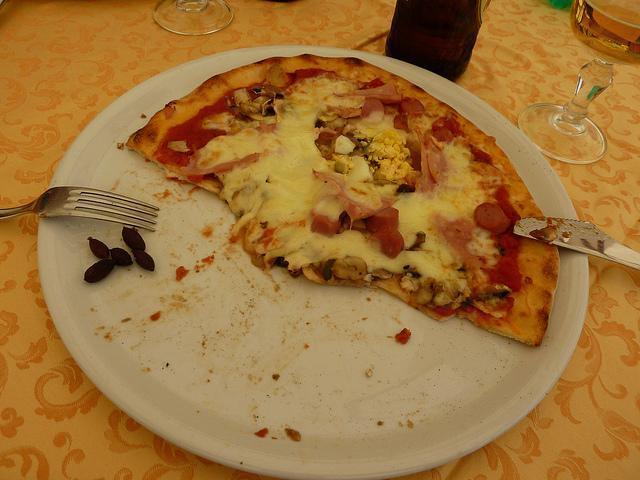How many knives are there?
Give a very brief answer. 1. How many teeth are on the plate?
Give a very brief answer. 0. How many utensils can be seen?
Give a very brief answer. 2. How many wine glasses are visible?
Give a very brief answer. 2. How many baby elephants are in the picture?
Give a very brief answer. 0. 